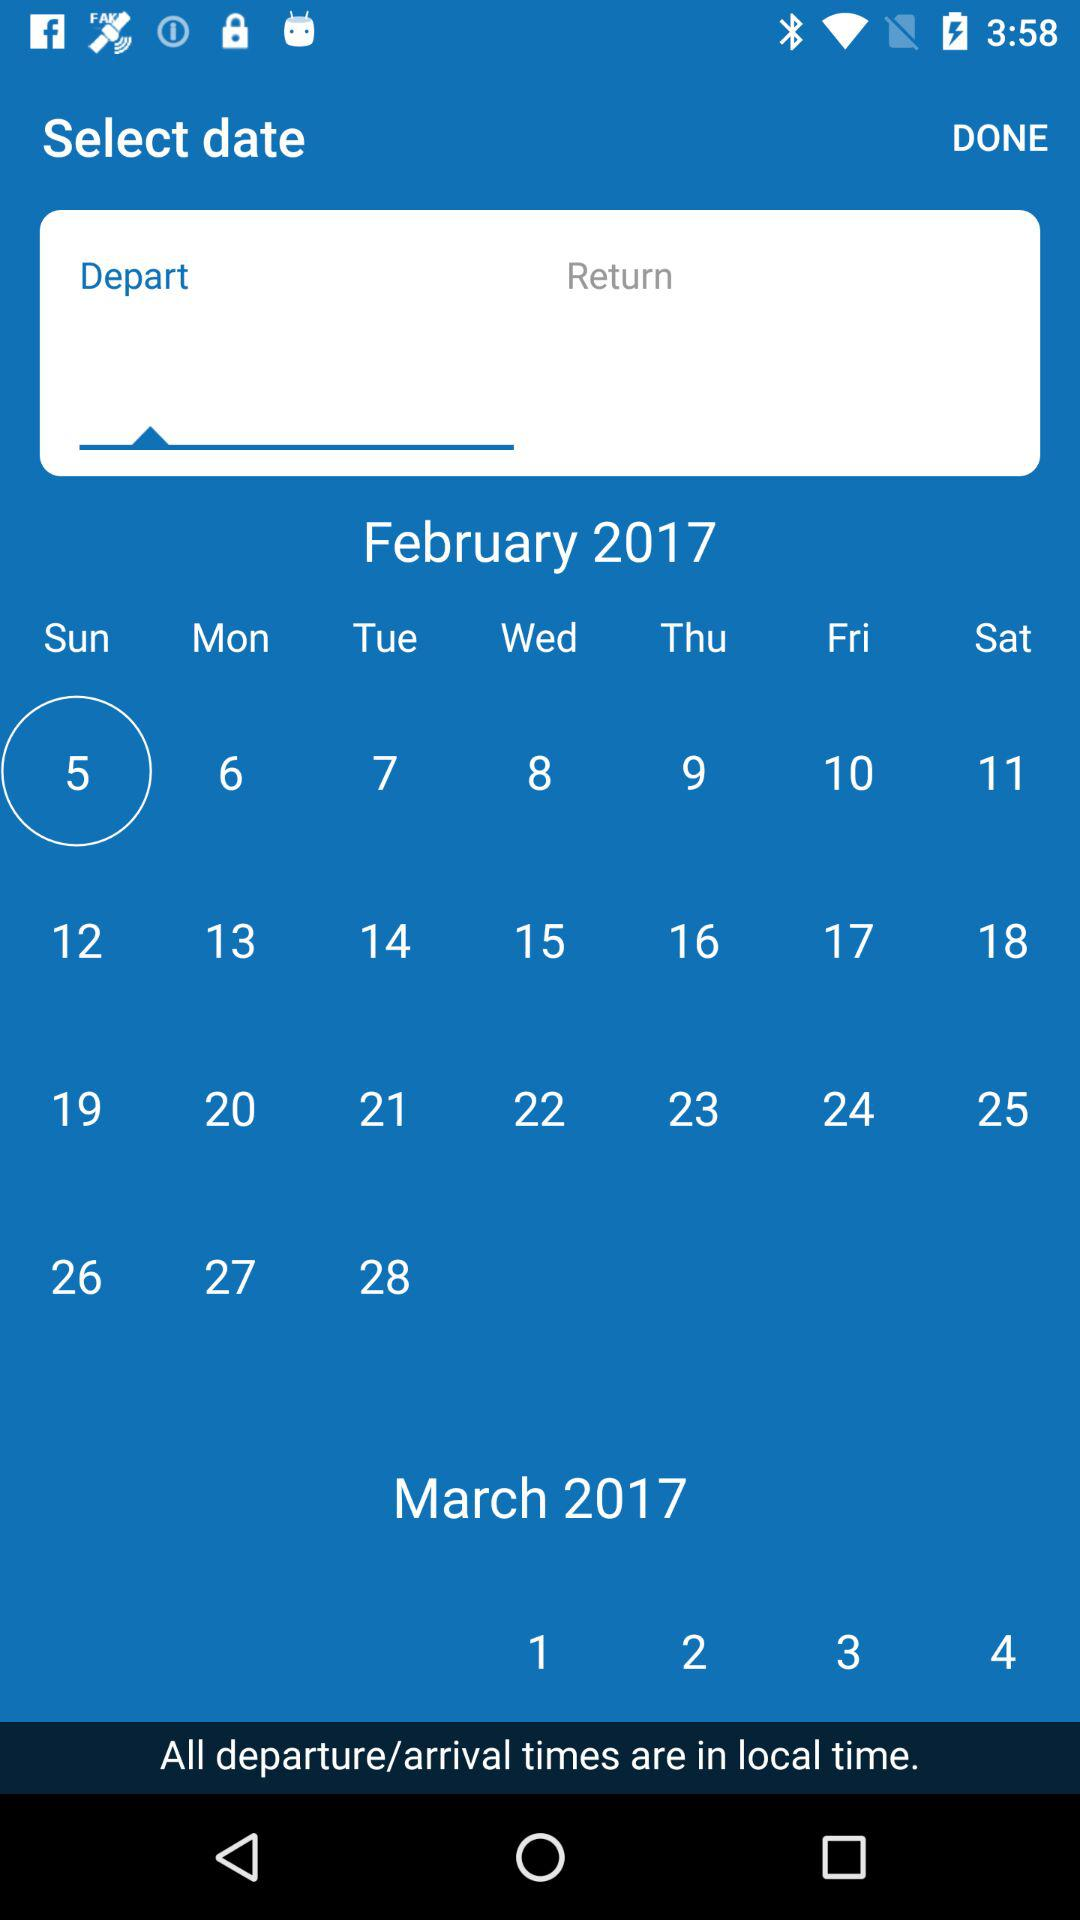What is the day on February 5? The day is Sunday. 